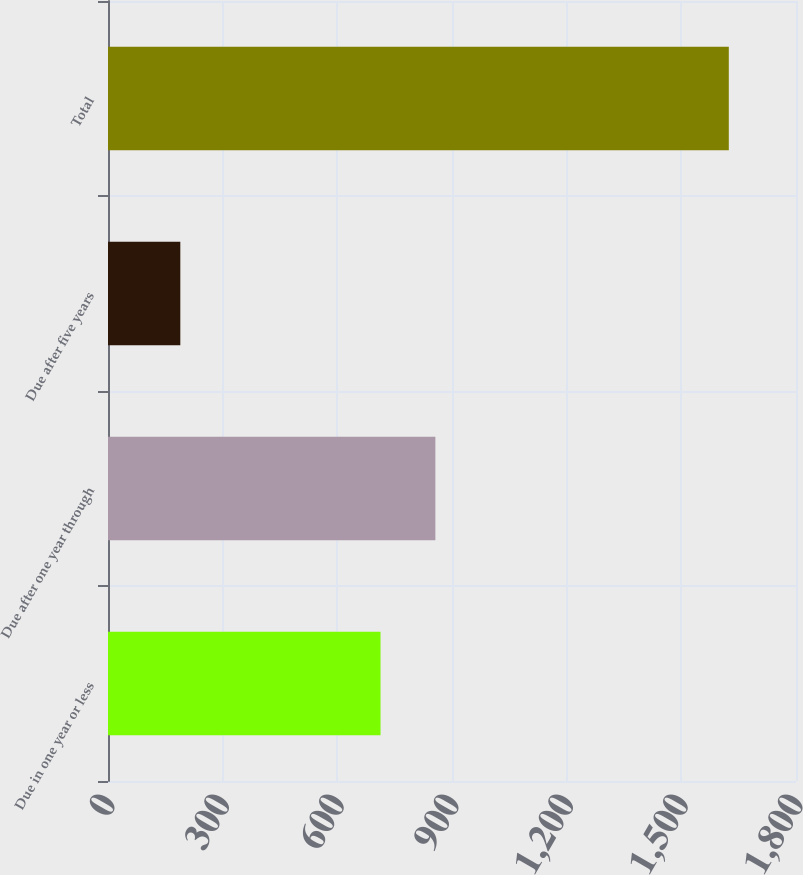Convert chart. <chart><loc_0><loc_0><loc_500><loc_500><bar_chart><fcel>Due in one year or less<fcel>Due after one year through<fcel>Due after five years<fcel>Total<nl><fcel>713<fcel>856.5<fcel>189.2<fcel>1624.2<nl></chart> 